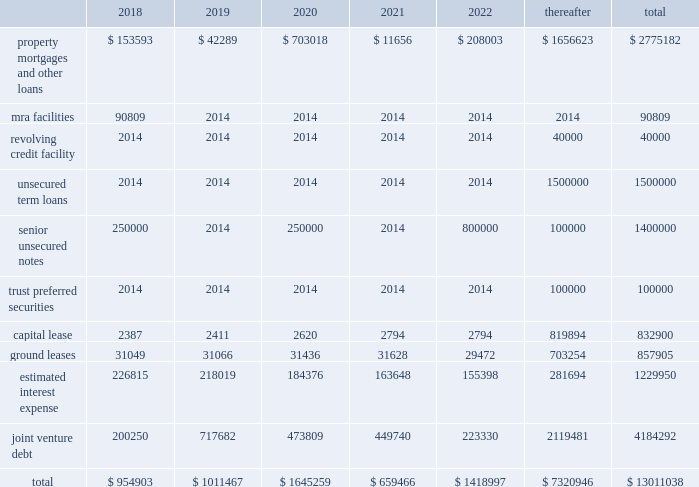Restrictive covenants the terms of the 2017 credit facility and certain of our senior unsecured notes include certain restrictions and covenants which may limit , among other things , our ability to pay dividends , make certain types of investments , incur additional indebtedness , incur liens and enter into negative pledge agreements and dispose of assets , and which require compliance with financial ratios relating to the maximum ratio of total indebtedness to total asset value , a minimum ratio of ebitda to fixed charges , a maximum ratio of secured indebtedness to total asset value and a maximum ratio of unsecured indebtedness to unencumbered asset value .
The dividend restriction referred to above provides that , we will not during any time when a default is continuing , make distributions with respect to common stock or other equity interests , except to enable the company to continue to qualify as a reit for federal income tax purposes .
As of december a031 , 2017 and 2016 , we were in compliance with all such covenants .
Junior subordinated deferrable interest debentures in june a02005 , the company and the operating partnership issued $ 100.0 a0million in unsecured trust preferred securities through a newly formed trust , sl a0green capital trust i , or the trust , which is a wholly-owned subsidiary of the operating partnership .
The securities mature in 2035 and bear interest at a floating rate of 125 a0basis points over the three-month libor .
Interest payments may be deferred for a period of up to eight consecutive quarters if the operating partnership exercises its right to defer such payments .
The trust preferred securities are redeemable at the option of the operating partnership , in whole or in part , with no prepayment premium .
We do not consolidate the trust even though it is a variable interest entity as we are not the primary beneficiary .
Because the trust is not consolidated , we have recorded the debt on our consolidated balance sheets and the related payments are classified as interest expense .
Interest rate risk we are exposed to changes in interest rates primarily from our variable rate debt .
Our exposure to interest rate fluctuations are managed through either the use of interest rate derivative instru- ments and/or through our variable rate debt and preferred equity investments .
A hypothetical 100 a0basis point increase in interest rates along the entire interest rate curve for a02017 would increase our consolidated annual interest cost , net of interest income from variable rate debt and preferred equity investments , by $ 2.7 a0mil- lion and would increase our share of joint venture annual interest cost by $ 17.2 a0million .
At december a031 , 2017 , 61.5% ( 61.5 % ) of our $ 2.1 a0bil- lion debt and preferred equity portfolio is indexed to libor .
We recognize most derivatives on the balance sheet at fair value .
Derivatives that are not hedges are adjusted to fair value through income .
If a derivative is considered a hedge , depending on the nature of the hedge , changes in the fair value of the derivative will either be offset against the change in fair value of the hedged asset , liability , or firm commitment through earnings , or recog- nized in other comprehensive income until the hedged item is recognized in earnings .
The ineffective portion of a derivative 2019s change in fair value is immediately recognized in a0earnings .
Our long-term debt of $ 4.3 a0billion bears interest at fixed rates , and therefore the fair value of these instruments is affected by changes in the market interest rates .
Our variable rate debt and variable rate joint venture debt as of december a031 , 2017 bore interest based on a spread of libor plus 100 a0basis points to libor plus 415 a0basis points .
Contractual obligations the combined aggregate principal maturities of mortgages and other loans payable , the 2017 credit facility , senior unsecured notes ( net of discount ) , trust preferred securities , our share of joint venture debt , including as-of-right extension options and put options , estimated interest expense , and our obligations under our capital lease and ground leases , as of december a031 , 2017 are as follows ( in a0thousands ) : .

What was the 2019 rate of increase in capital lease payments? 
Computations: ((2411 - 2387) / 2387)
Answer: 0.01005. Restrictive covenants the terms of the 2017 credit facility and certain of our senior unsecured notes include certain restrictions and covenants which may limit , among other things , our ability to pay dividends , make certain types of investments , incur additional indebtedness , incur liens and enter into negative pledge agreements and dispose of assets , and which require compliance with financial ratios relating to the maximum ratio of total indebtedness to total asset value , a minimum ratio of ebitda to fixed charges , a maximum ratio of secured indebtedness to total asset value and a maximum ratio of unsecured indebtedness to unencumbered asset value .
The dividend restriction referred to above provides that , we will not during any time when a default is continuing , make distributions with respect to common stock or other equity interests , except to enable the company to continue to qualify as a reit for federal income tax purposes .
As of december a031 , 2017 and 2016 , we were in compliance with all such covenants .
Junior subordinated deferrable interest debentures in june a02005 , the company and the operating partnership issued $ 100.0 a0million in unsecured trust preferred securities through a newly formed trust , sl a0green capital trust i , or the trust , which is a wholly-owned subsidiary of the operating partnership .
The securities mature in 2035 and bear interest at a floating rate of 125 a0basis points over the three-month libor .
Interest payments may be deferred for a period of up to eight consecutive quarters if the operating partnership exercises its right to defer such payments .
The trust preferred securities are redeemable at the option of the operating partnership , in whole or in part , with no prepayment premium .
We do not consolidate the trust even though it is a variable interest entity as we are not the primary beneficiary .
Because the trust is not consolidated , we have recorded the debt on our consolidated balance sheets and the related payments are classified as interest expense .
Interest rate risk we are exposed to changes in interest rates primarily from our variable rate debt .
Our exposure to interest rate fluctuations are managed through either the use of interest rate derivative instru- ments and/or through our variable rate debt and preferred equity investments .
A hypothetical 100 a0basis point increase in interest rates along the entire interest rate curve for a02017 would increase our consolidated annual interest cost , net of interest income from variable rate debt and preferred equity investments , by $ 2.7 a0mil- lion and would increase our share of joint venture annual interest cost by $ 17.2 a0million .
At december a031 , 2017 , 61.5% ( 61.5 % ) of our $ 2.1 a0bil- lion debt and preferred equity portfolio is indexed to libor .
We recognize most derivatives on the balance sheet at fair value .
Derivatives that are not hedges are adjusted to fair value through income .
If a derivative is considered a hedge , depending on the nature of the hedge , changes in the fair value of the derivative will either be offset against the change in fair value of the hedged asset , liability , or firm commitment through earnings , or recog- nized in other comprehensive income until the hedged item is recognized in earnings .
The ineffective portion of a derivative 2019s change in fair value is immediately recognized in a0earnings .
Our long-term debt of $ 4.3 a0billion bears interest at fixed rates , and therefore the fair value of these instruments is affected by changes in the market interest rates .
Our variable rate debt and variable rate joint venture debt as of december a031 , 2017 bore interest based on a spread of libor plus 100 a0basis points to libor plus 415 a0basis points .
Contractual obligations the combined aggregate principal maturities of mortgages and other loans payable , the 2017 credit facility , senior unsecured notes ( net of discount ) , trust preferred securities , our share of joint venture debt , including as-of-right extension options and put options , estimated interest expense , and our obligations under our capital lease and ground leases , as of december a031 , 2017 are as follows ( in a0thousands ) : .

What was the 2019 rate of decrease in estimated interest expense payments? 
Computations: ((226815 - 218019) / 226815)
Answer: 0.03878. 